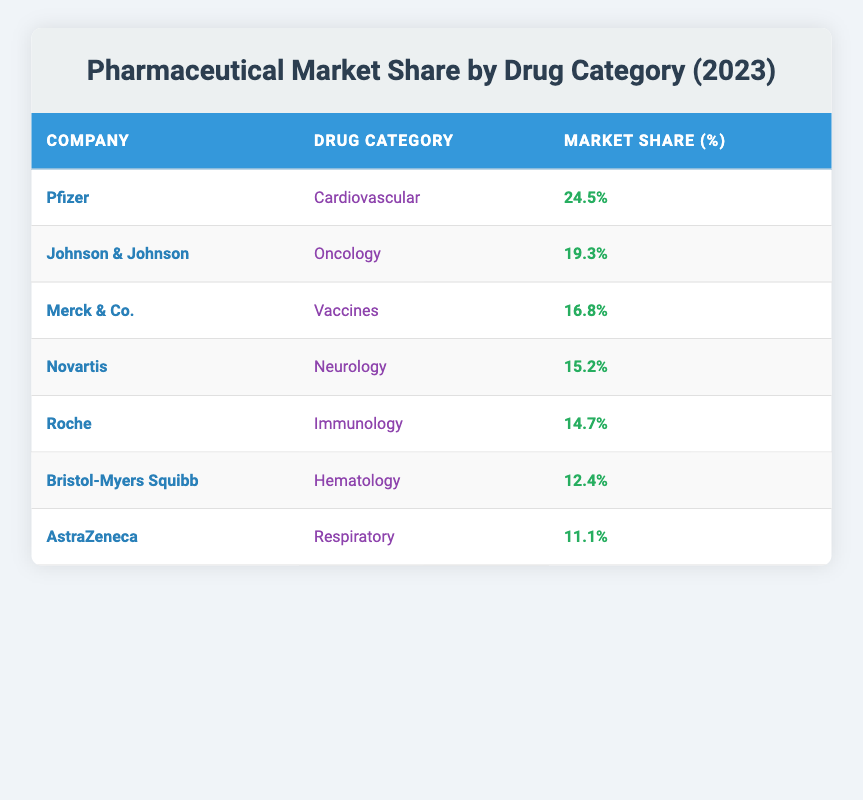What is the market share percentage of Pfizer in the cardiovascular category? From the table, Pfizer is listed in the cardiovascular category, and the corresponding market share percentage is found next to it. So, the market share percentage for Pfizer in this category is 24.5%.
Answer: 24.5% Which company has the highest market share in oncology? Upon examining the table, Johnson & Johnson is the only entry in the oncology category, and its market share is presented next to it. Therefore, it has the highest market share in the oncology category, which is 19.3%.
Answer: 19.3% What is the total market share percentage of Merck & Co. and Novartis combined? The market share percentages for Merck & Co. (16.8%) and Novartis (15.2%) can be summed to get the total. Adding them gives 16.8% + 15.2% = 32%.
Answer: 32% Does AstraZeneca have a higher market share percentage than Roche? By comparing the market share percentages, AstraZeneca has 11.1% and Roche has 14.7%. Since 11.1% is less than 14.7%, the answer is no, AstraZeneca does not have a higher market share than Roche.
Answer: No What percentage of market share do Bristol-Myers Squibb and Roche have together, and do they hold more than 30%? Adding the market shares of Bristol-Myers Squibb (12.4%) and Roche (14.7%) gives us a total of 12.4% + 14.7% = 27.1%. Since 27.1% is less than 30%, they do not hold more than 30%.
Answer: No Which drug category has the lowest market share percentage and what is that percentage? Reviewing the table, AstraZeneca in the respiratory category has the lowest market share at 11.1%. We determine this by comparing all other percentages listed.
Answer: 11.1% Is there any company listed under both oncology and hematology categories in this table? Upon checking the table, no company is repeated across the oncology and hematology categories. Therefore, the answer is no.
Answer: No What is the average market share percentage of the companies listed in the table? The total market share percentage is calculated by summing all the individual percentages (24.5 + 19.3 + 16.8 + 15.2 + 14.7 + 12.4 + 11.1) which equals 113.0%. There are 7 companies, so dividing by 7 gives an average of approximately 16.14%.
Answer: 16.14% 